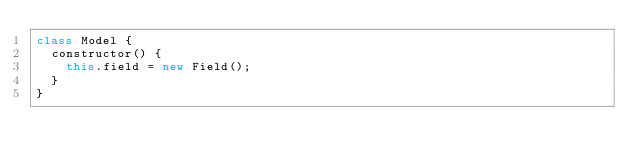<code> <loc_0><loc_0><loc_500><loc_500><_JavaScript_>class Model {
  constructor() {
    this.field = new Field();
  }
}
</code> 